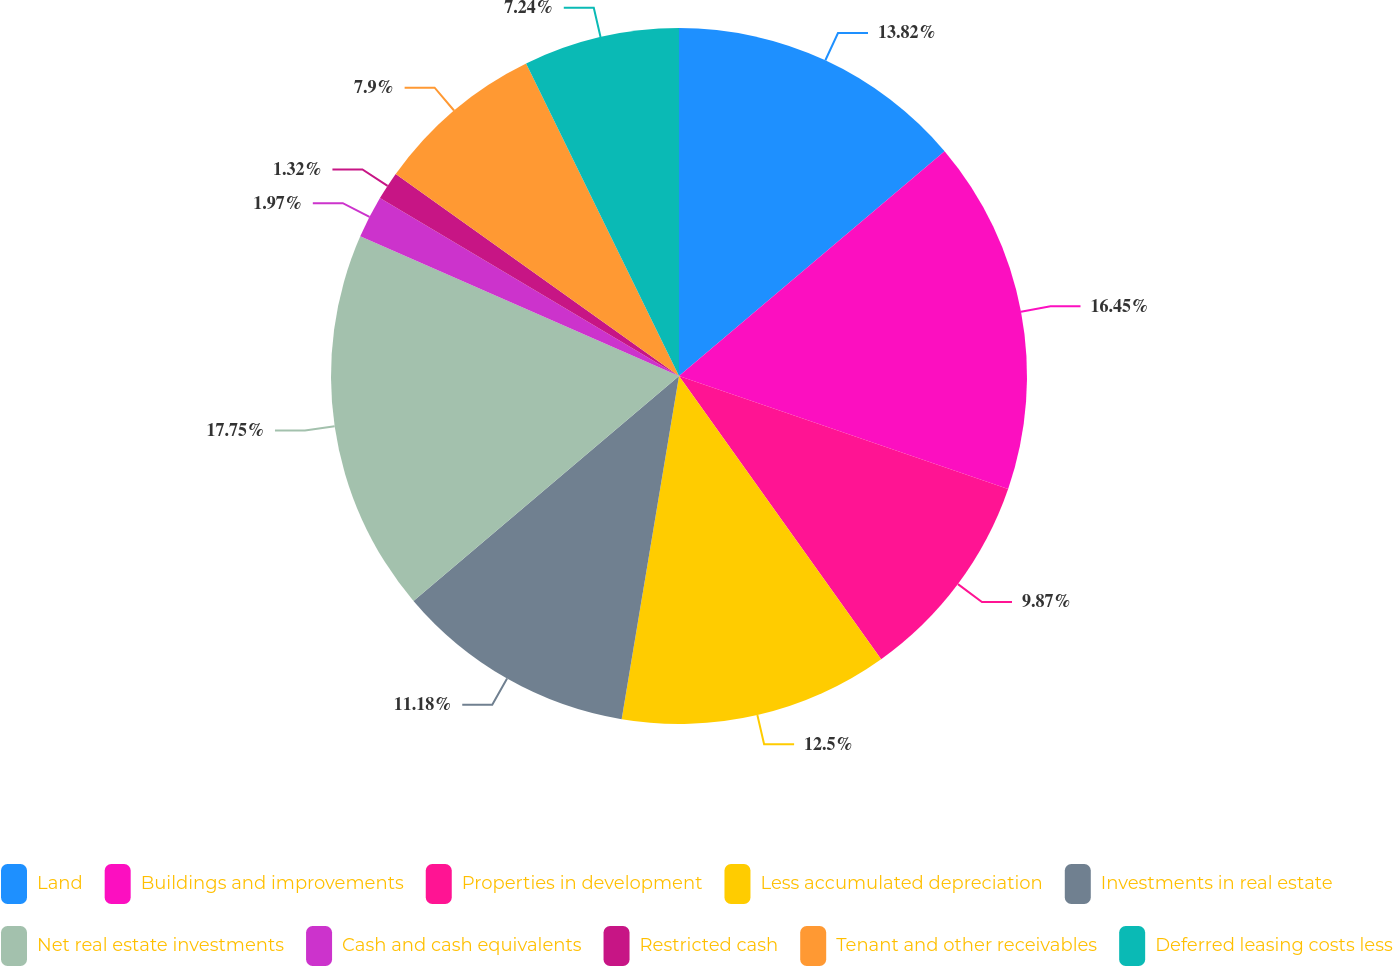Convert chart to OTSL. <chart><loc_0><loc_0><loc_500><loc_500><pie_chart><fcel>Land<fcel>Buildings and improvements<fcel>Properties in development<fcel>Less accumulated depreciation<fcel>Investments in real estate<fcel>Net real estate investments<fcel>Cash and cash equivalents<fcel>Restricted cash<fcel>Tenant and other receivables<fcel>Deferred leasing costs less<nl><fcel>13.82%<fcel>16.45%<fcel>9.87%<fcel>12.5%<fcel>11.18%<fcel>17.76%<fcel>1.97%<fcel>1.32%<fcel>7.9%<fcel>7.24%<nl></chart> 